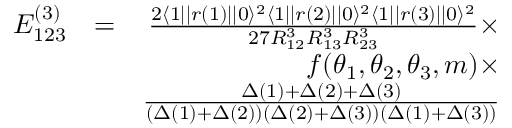<formula> <loc_0><loc_0><loc_500><loc_500>\begin{array} { r l r } { E _ { 1 2 3 } ^ { ( 3 ) } } & { = } & { \frac { 2 \langle 1 | | r ( 1 ) | | 0 \rangle ^ { 2 } \langle 1 | | r ( 2 ) | | 0 \rangle ^ { 2 } \langle 1 | | r ( 3 ) | | 0 \rangle ^ { 2 } } { 2 7 R _ { 1 2 } ^ { 3 } R _ { 1 3 } ^ { 3 } R _ { 2 3 } ^ { 3 } } \times } \\ & { f ( \theta _ { 1 } , \theta _ { 2 } , \theta _ { 3 } , m ) \times } \\ & { \frac { \Delta ( 1 ) + \Delta ( 2 ) + \Delta ( 3 ) } { ( \Delta ( 1 ) + \Delta ( 2 ) ) ( \Delta ( 2 ) + \Delta ( 3 ) ) ( \Delta ( 1 ) + \Delta ( 3 ) ) } } \end{array}</formula> 